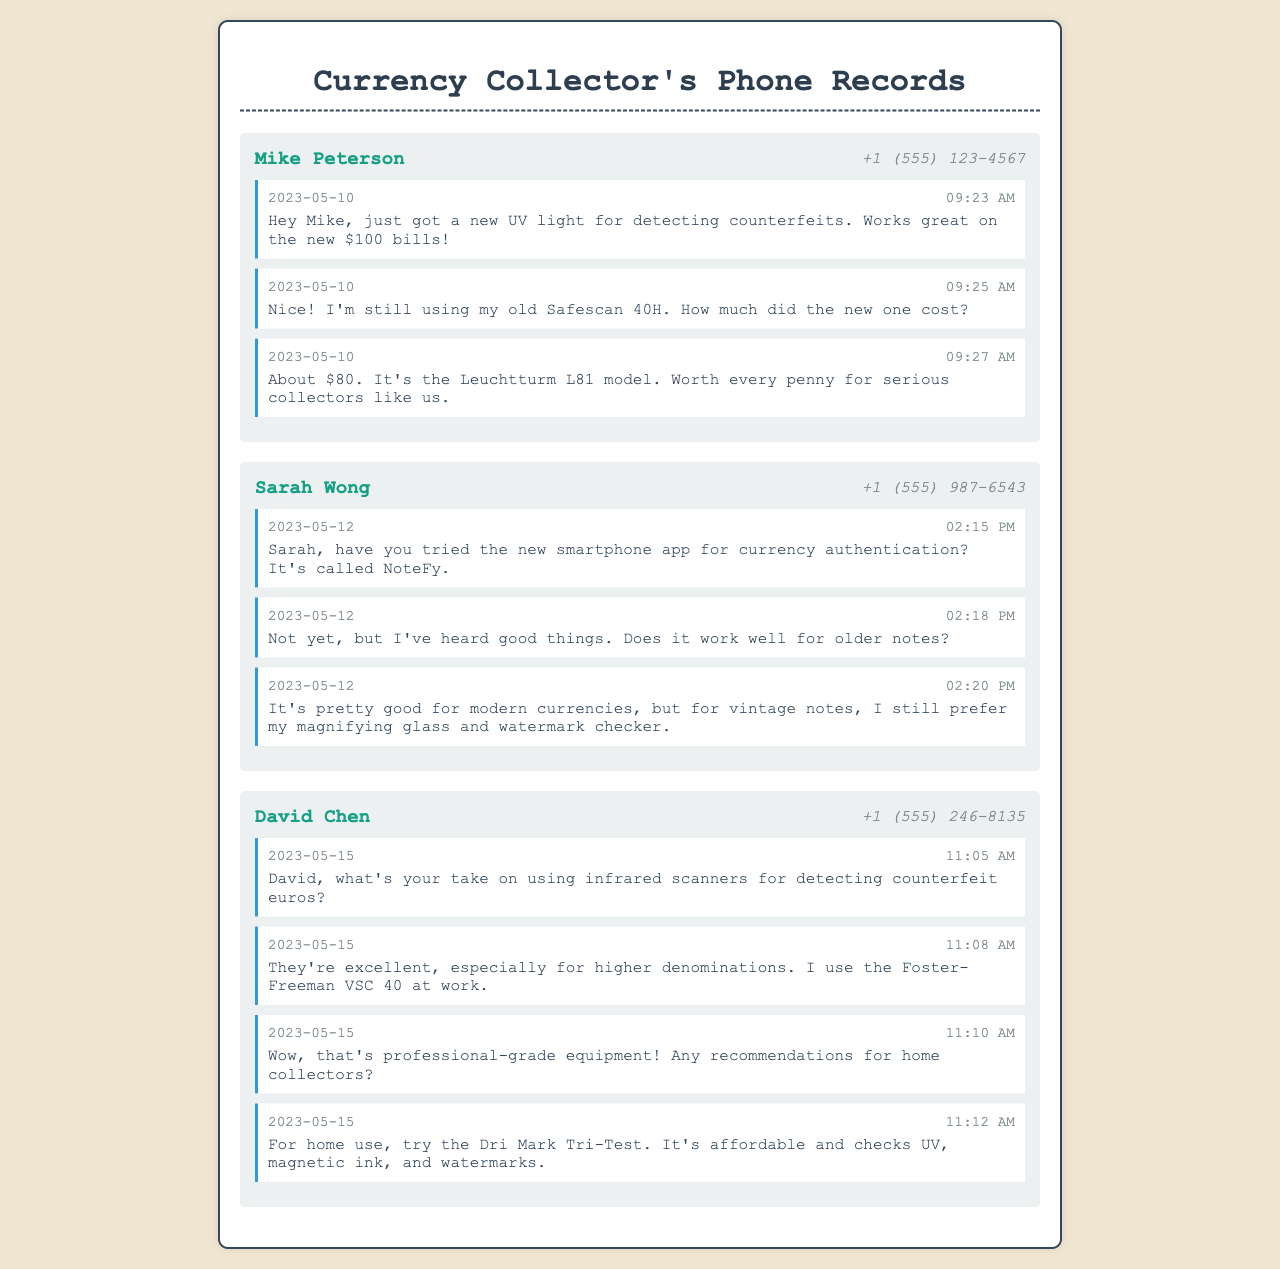What date did Mike receive his new UV light? The document states that Mike mentioned getting a new UV light on May 10, 2023.
Answer: May 10, 2023 How much did Mike's new UV light cost? The message indicates that the UV light cost about $80.
Answer: $80 What is the model of the UV light mentioned by Mike? The document specifies that the model is the Leuchtturm L81.
Answer: Leuchtturm L81 Which app did Sarah inquire about? Sarah asked about the NoteFy app for currency authentication.
Answer: NoteFy What piece of equipment does David use at work for detection? David mentioned using the Foster-Freeman VSC 40 at work.
Answer: Foster-Freeman VSC 40 What is a recommended tool for home collectors according to David? David recommends the Dri Mark Tri-Test for home use.
Answer: Dri Mark Tri-Test What time did Sarah send her first message on May 12? Sarah's first message on May 12 was sent at 2:15 PM.
Answer: 2:15 PM Which collector uses an old Safescan model? The document states that Mike is still using his old Safescan 40H.
Answer: Mike 